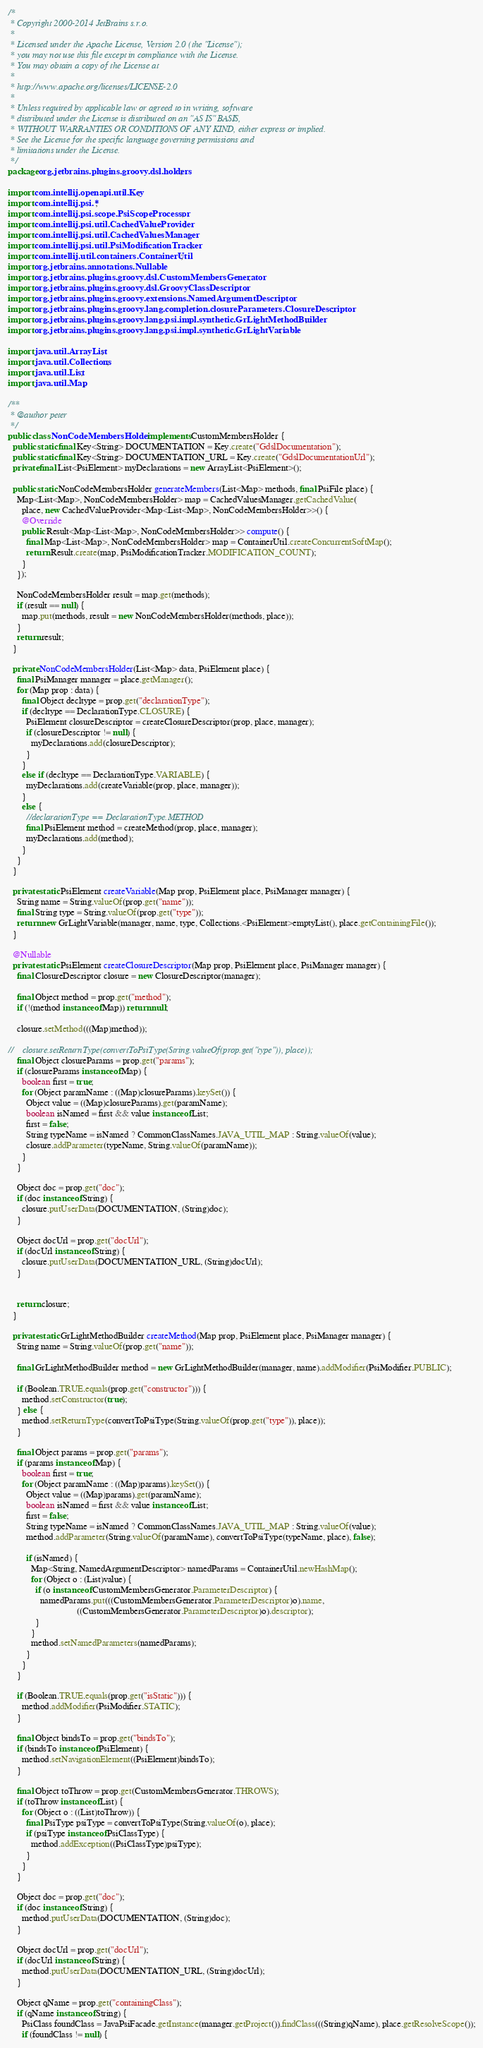<code> <loc_0><loc_0><loc_500><loc_500><_Java_>/*
 * Copyright 2000-2014 JetBrains s.r.o.
 *
 * Licensed under the Apache License, Version 2.0 (the "License");
 * you may not use this file except in compliance with the License.
 * You may obtain a copy of the License at
 *
 * http://www.apache.org/licenses/LICENSE-2.0
 *
 * Unless required by applicable law or agreed to in writing, software
 * distributed under the License is distributed on an "AS IS" BASIS,
 * WITHOUT WARRANTIES OR CONDITIONS OF ANY KIND, either express or implied.
 * See the License for the specific language governing permissions and
 * limitations under the License.
 */
package org.jetbrains.plugins.groovy.dsl.holders;

import com.intellij.openapi.util.Key;
import com.intellij.psi.*;
import com.intellij.psi.scope.PsiScopeProcessor;
import com.intellij.psi.util.CachedValueProvider;
import com.intellij.psi.util.CachedValuesManager;
import com.intellij.psi.util.PsiModificationTracker;
import com.intellij.util.containers.ContainerUtil;
import org.jetbrains.annotations.Nullable;
import org.jetbrains.plugins.groovy.dsl.CustomMembersGenerator;
import org.jetbrains.plugins.groovy.dsl.GroovyClassDescriptor;
import org.jetbrains.plugins.groovy.extensions.NamedArgumentDescriptor;
import org.jetbrains.plugins.groovy.lang.completion.closureParameters.ClosureDescriptor;
import org.jetbrains.plugins.groovy.lang.psi.impl.synthetic.GrLightMethodBuilder;
import org.jetbrains.plugins.groovy.lang.psi.impl.synthetic.GrLightVariable;

import java.util.ArrayList;
import java.util.Collections;
import java.util.List;
import java.util.Map;

/**
 * @author peter
 */
public class NonCodeMembersHolder implements CustomMembersHolder {
  public static final Key<String> DOCUMENTATION = Key.create("GdslDocumentation");
  public static final Key<String> DOCUMENTATION_URL = Key.create("GdslDocumentationUrl");
  private final List<PsiElement> myDeclarations = new ArrayList<PsiElement>();

  public static NonCodeMembersHolder generateMembers(List<Map> methods, final PsiFile place) {
    Map<List<Map>, NonCodeMembersHolder> map = CachedValuesManager.getCachedValue(
      place, new CachedValueProvider<Map<List<Map>, NonCodeMembersHolder>>() {
      @Override
      public Result<Map<List<Map>, NonCodeMembersHolder>> compute() {
        final Map<List<Map>, NonCodeMembersHolder> map = ContainerUtil.createConcurrentSoftMap();
        return Result.create(map, PsiModificationTracker.MODIFICATION_COUNT);
      }
    });

    NonCodeMembersHolder result = map.get(methods);
    if (result == null) {
      map.put(methods, result = new NonCodeMembersHolder(methods, place));
    }
    return result;
  }

  private NonCodeMembersHolder(List<Map> data, PsiElement place) {
    final PsiManager manager = place.getManager();
    for (Map prop : data) {
      final Object decltype = prop.get("declarationType");
      if (decltype == DeclarationType.CLOSURE) {
        PsiElement closureDescriptor = createClosureDescriptor(prop, place, manager);
        if (closureDescriptor != null) {
          myDeclarations.add(closureDescriptor);
        }
      }
      else if (decltype == DeclarationType.VARIABLE) {
        myDeclarations.add(createVariable(prop, place, manager));
      }
      else {
        //declarationType == DeclarationType.METHOD
        final PsiElement method = createMethod(prop, place, manager);
        myDeclarations.add(method);
      }
    }
  }

  private static PsiElement createVariable(Map prop, PsiElement place, PsiManager manager) {
    String name = String.valueOf(prop.get("name"));
    final String type = String.valueOf(prop.get("type"));
    return new GrLightVariable(manager, name, type, Collections.<PsiElement>emptyList(), place.getContainingFile());
  }

  @Nullable
  private static PsiElement createClosureDescriptor(Map prop, PsiElement place, PsiManager manager) {
    final ClosureDescriptor closure = new ClosureDescriptor(manager);

    final Object method = prop.get("method");
    if (!(method instanceof Map)) return null;

    closure.setMethod(((Map)method));

//    closure.setReturnType(convertToPsiType(String.valueOf(prop.get("type")), place));
    final Object closureParams = prop.get("params");
    if (closureParams instanceof Map) {
      boolean first = true;
      for (Object paramName : ((Map)closureParams).keySet()) {
        Object value = ((Map)closureParams).get(paramName);
        boolean isNamed = first && value instanceof List;
        first = false;
        String typeName = isNamed ? CommonClassNames.JAVA_UTIL_MAP : String.valueOf(value);
        closure.addParameter(typeName, String.valueOf(paramName));
      }
    }

    Object doc = prop.get("doc");
    if (doc instanceof String) {
      closure.putUserData(DOCUMENTATION, (String)doc);
    }

    Object docUrl = prop.get("docUrl");
    if (docUrl instanceof String) {
      closure.putUserData(DOCUMENTATION_URL, (String)docUrl);
    }


    return closure;
  }

  private static GrLightMethodBuilder createMethod(Map prop, PsiElement place, PsiManager manager) {
    String name = String.valueOf(prop.get("name"));

    final GrLightMethodBuilder method = new GrLightMethodBuilder(manager, name).addModifier(PsiModifier.PUBLIC);

    if (Boolean.TRUE.equals(prop.get("constructor"))) {
      method.setConstructor(true);
    } else {
      method.setReturnType(convertToPsiType(String.valueOf(prop.get("type")), place));
    }

    final Object params = prop.get("params");
    if (params instanceof Map) {
      boolean first = true;
      for (Object paramName : ((Map)params).keySet()) {
        Object value = ((Map)params).get(paramName);
        boolean isNamed = first && value instanceof List;
        first = false;
        String typeName = isNamed ? CommonClassNames.JAVA_UTIL_MAP : String.valueOf(value);
        method.addParameter(String.valueOf(paramName), convertToPsiType(typeName, place), false);

        if (isNamed) {
          Map<String, NamedArgumentDescriptor> namedParams = ContainerUtil.newHashMap();
          for (Object o : (List)value) {
            if (o instanceof CustomMembersGenerator.ParameterDescriptor) {
              namedParams.put(((CustomMembersGenerator.ParameterDescriptor)o).name,
                              ((CustomMembersGenerator.ParameterDescriptor)o).descriptor);
            }
          }
          method.setNamedParameters(namedParams);
        }
      }
    }

    if (Boolean.TRUE.equals(prop.get("isStatic"))) {
      method.addModifier(PsiModifier.STATIC);
    }

    final Object bindsTo = prop.get("bindsTo");
    if (bindsTo instanceof PsiElement) {
      method.setNavigationElement((PsiElement)bindsTo);
    }

    final Object toThrow = prop.get(CustomMembersGenerator.THROWS);
    if (toThrow instanceof List) {
      for (Object o : ((List)toThrow)) {
        final PsiType psiType = convertToPsiType(String.valueOf(o), place);
        if (psiType instanceof PsiClassType) {
          method.addException((PsiClassType)psiType);
        }
      }
    }

    Object doc = prop.get("doc");
    if (doc instanceof String) {
      method.putUserData(DOCUMENTATION, (String)doc);
    }

    Object docUrl = prop.get("docUrl");
    if (docUrl instanceof String) {
      method.putUserData(DOCUMENTATION_URL, (String)docUrl);
    }

    Object qName = prop.get("containingClass");
    if (qName instanceof String) {
      PsiClass foundClass = JavaPsiFacade.getInstance(manager.getProject()).findClass(((String)qName), place.getResolveScope());
      if (foundClass != null) {</code> 